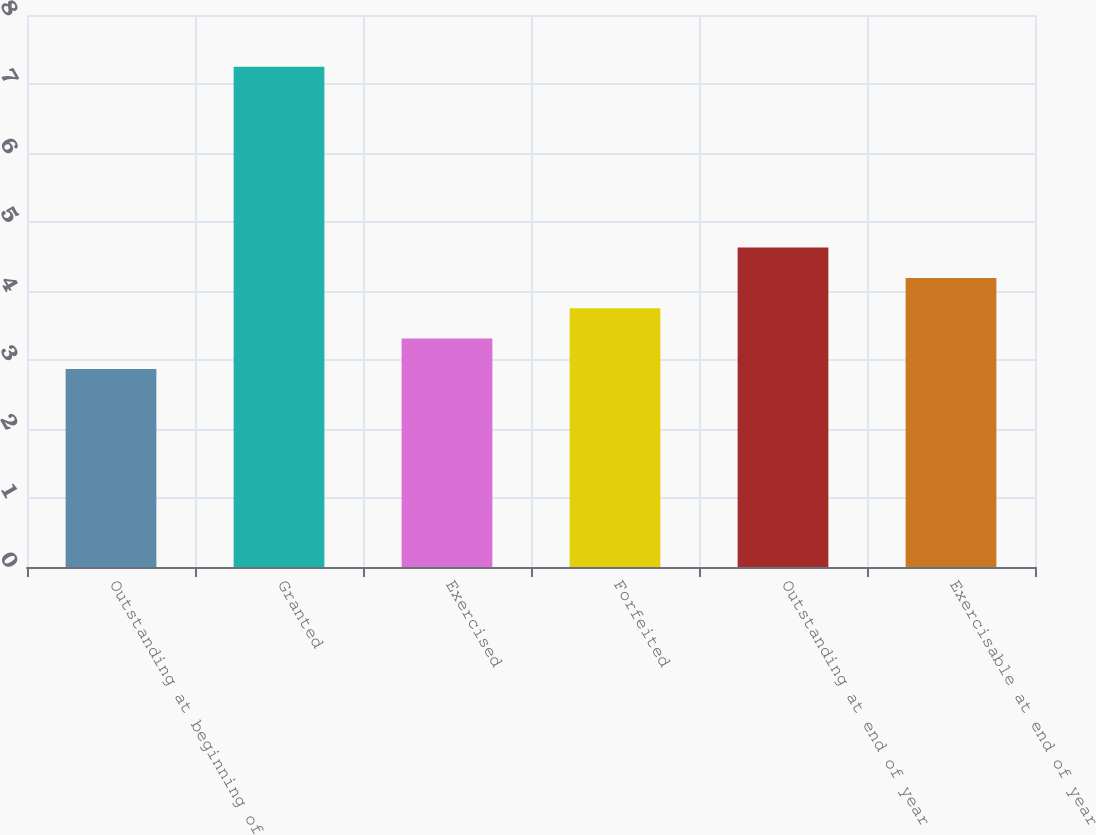<chart> <loc_0><loc_0><loc_500><loc_500><bar_chart><fcel>Outstanding at beginning of<fcel>Granted<fcel>Exercised<fcel>Forfeited<fcel>Outstanding at end of year<fcel>Exercisable at end of year<nl><fcel>2.87<fcel>7.25<fcel>3.31<fcel>3.75<fcel>4.63<fcel>4.19<nl></chart> 